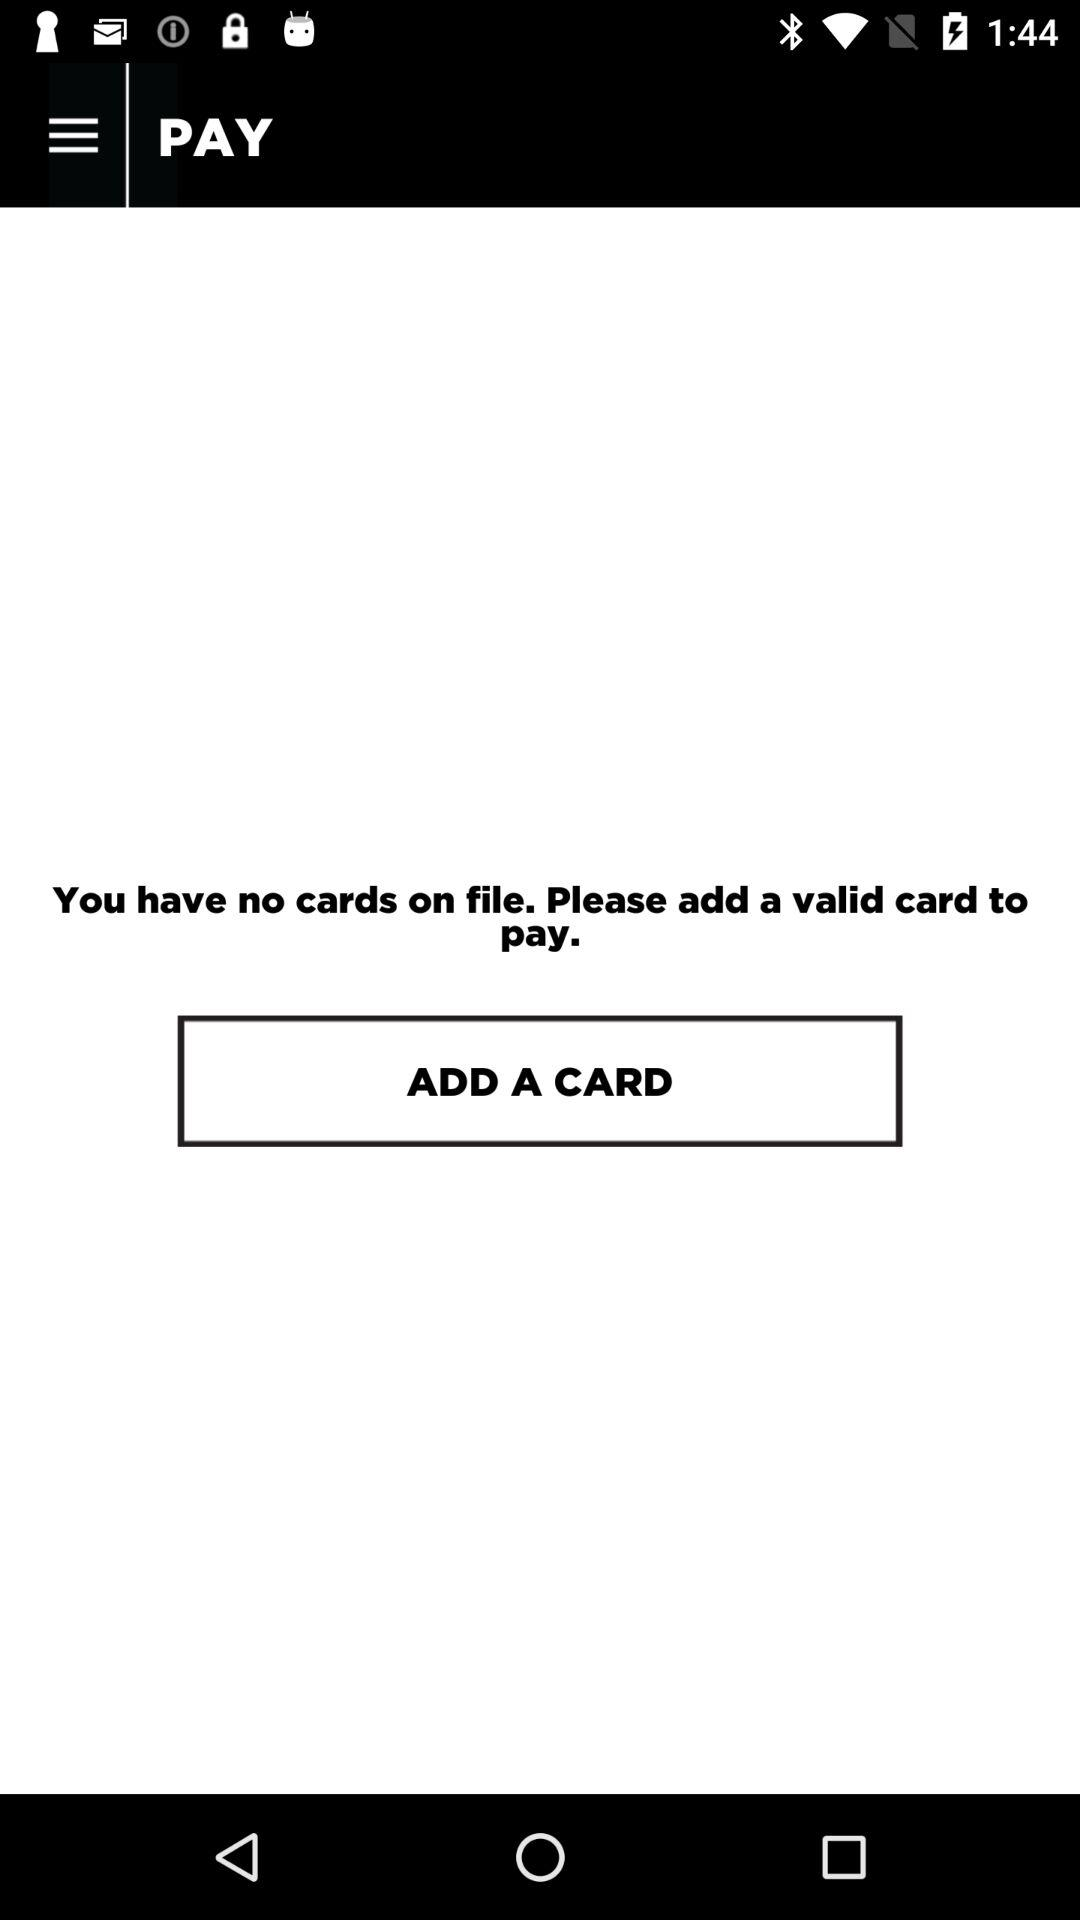What is the number on the card that is added?
When the provided information is insufficient, respond with <no answer>. <no answer> 